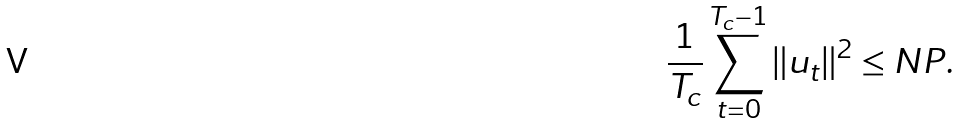Convert formula to latex. <formula><loc_0><loc_0><loc_500><loc_500>\frac { 1 } { T _ { c } } \sum _ { t = 0 } ^ { T _ { c } - 1 } \| u _ { t } \| ^ { 2 } \leq N P .</formula> 